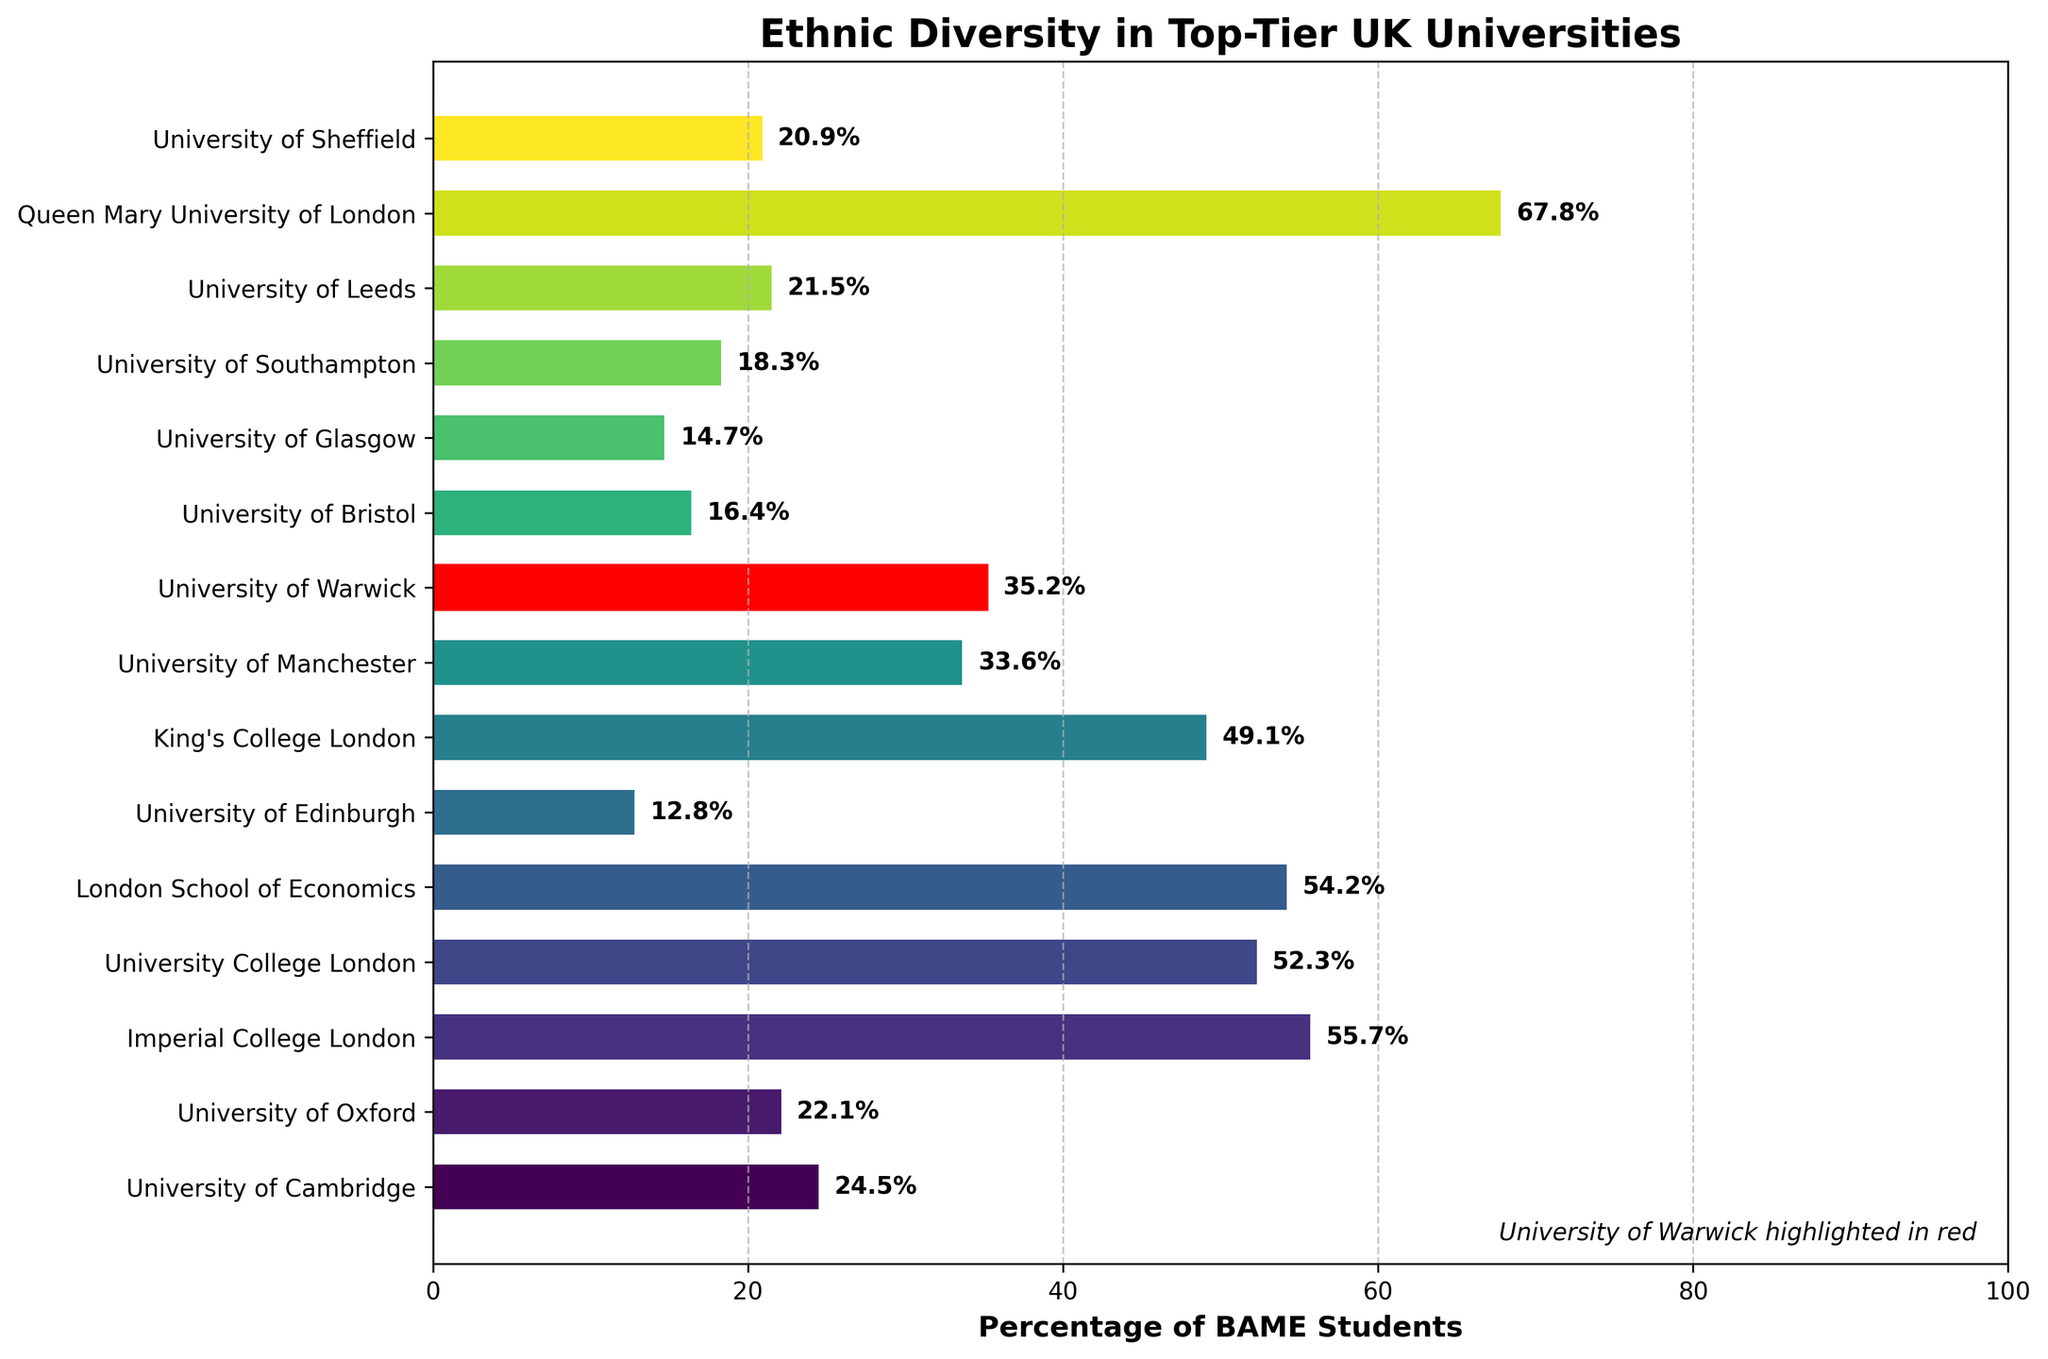Which university has the highest percentage of BAME students? The bar that extends the furthest to the right indicates Queen Mary University of London has the highest percentage of BAME students.
Answer: Queen Mary University of London Which university has a higher percentage of BAME students, University of Warwick or University of Cambridge? Comparing the lengths of the bars, University of Warwick (35.2%) has a higher percentage than the University of Cambridge (24.5%).
Answer: University of Warwick What's the average percentage of BAME students for the University of Manchester, University of Bristol, and University of Leeds? Calculate the average: (33.6% + 16.4% + 21.5%) / 3 = 71.5 / 3 = 23.83%
Answer: 23.83% By how much does the percentage of BAME students at King's College London exceed that at University of Glasgow? Subtract the University of Glasgow's percentage from King's College London's percentage: 49.1% - 14.7% = 34.4%
Answer: 34.4% Which university has the lowest percentage of BAME students? The shortest bar indicates that University of Edinburgh has the lowest percentage of BAME students.
Answer: University of Edinburgh How many universities have a percentage of BAME students above 50%? Count the bars extending beyond the 50% mark: Imperial College London, University College London, London School of Economics, Queen Mary University of London.
Answer: 4 What is the percentage difference between the University with the highest and the lowest BAME students? Calculate the difference: Queen Mary University of London (67.8%) - University of Edinburgh (12.8%) = 55%
Answer: 55% Is the percentage of BAME students at University College London closer to 50% than University of Leeds? University College London has 52.3% (close to 50) while University of Leeds has 21.5% (further from 50)
Answer: University College London What is the median percentage of BAME students among all listed universities? Arrange percentages in ascending order: 12.8, 14.7, 16.4, 18.3, 20.9, 21.5, 22.1, 24.5, 33.6, 35.2, 49.1, 52.3, 54.2, 55.7, 67.8. The median is the middle value: 24.5%
Answer: 24.5% What's the percentage of BAME students at Imperial College London? Look at the corresponding bar for Imperial College London: 55.7%
Answer: 55.7% 